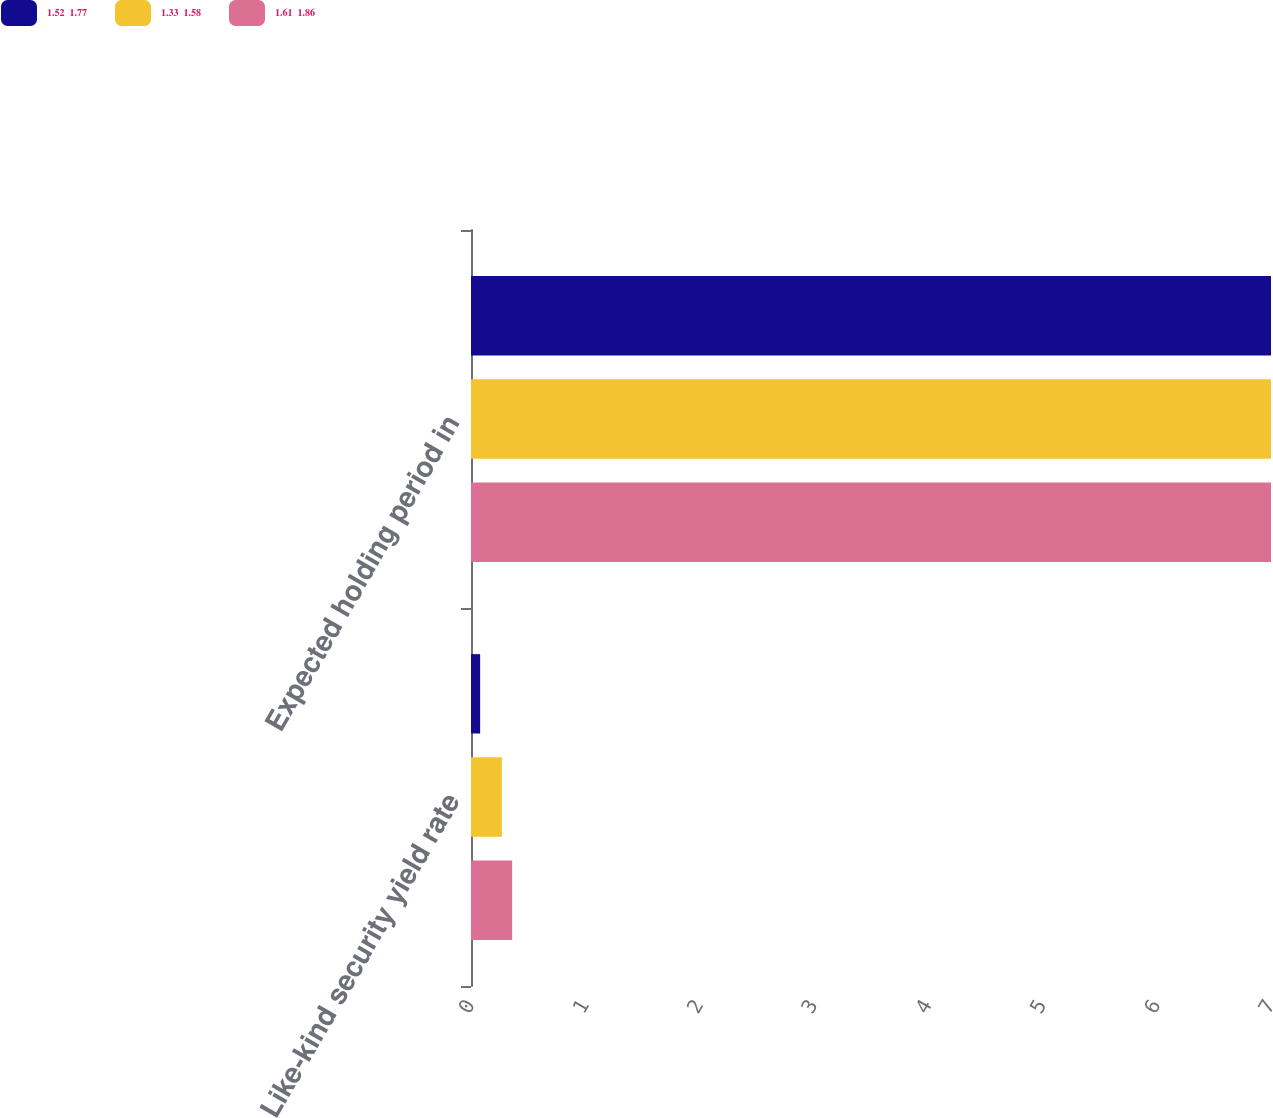Convert chart to OTSL. <chart><loc_0><loc_0><loc_500><loc_500><stacked_bar_chart><ecel><fcel>Like-kind security yield rate<fcel>Expected holding period in<nl><fcel>1.52  1.77<fcel>0.08<fcel>7<nl><fcel>1.33  1.58<fcel>0.27<fcel>7<nl><fcel>1.61  1.86<fcel>0.36<fcel>7<nl></chart> 